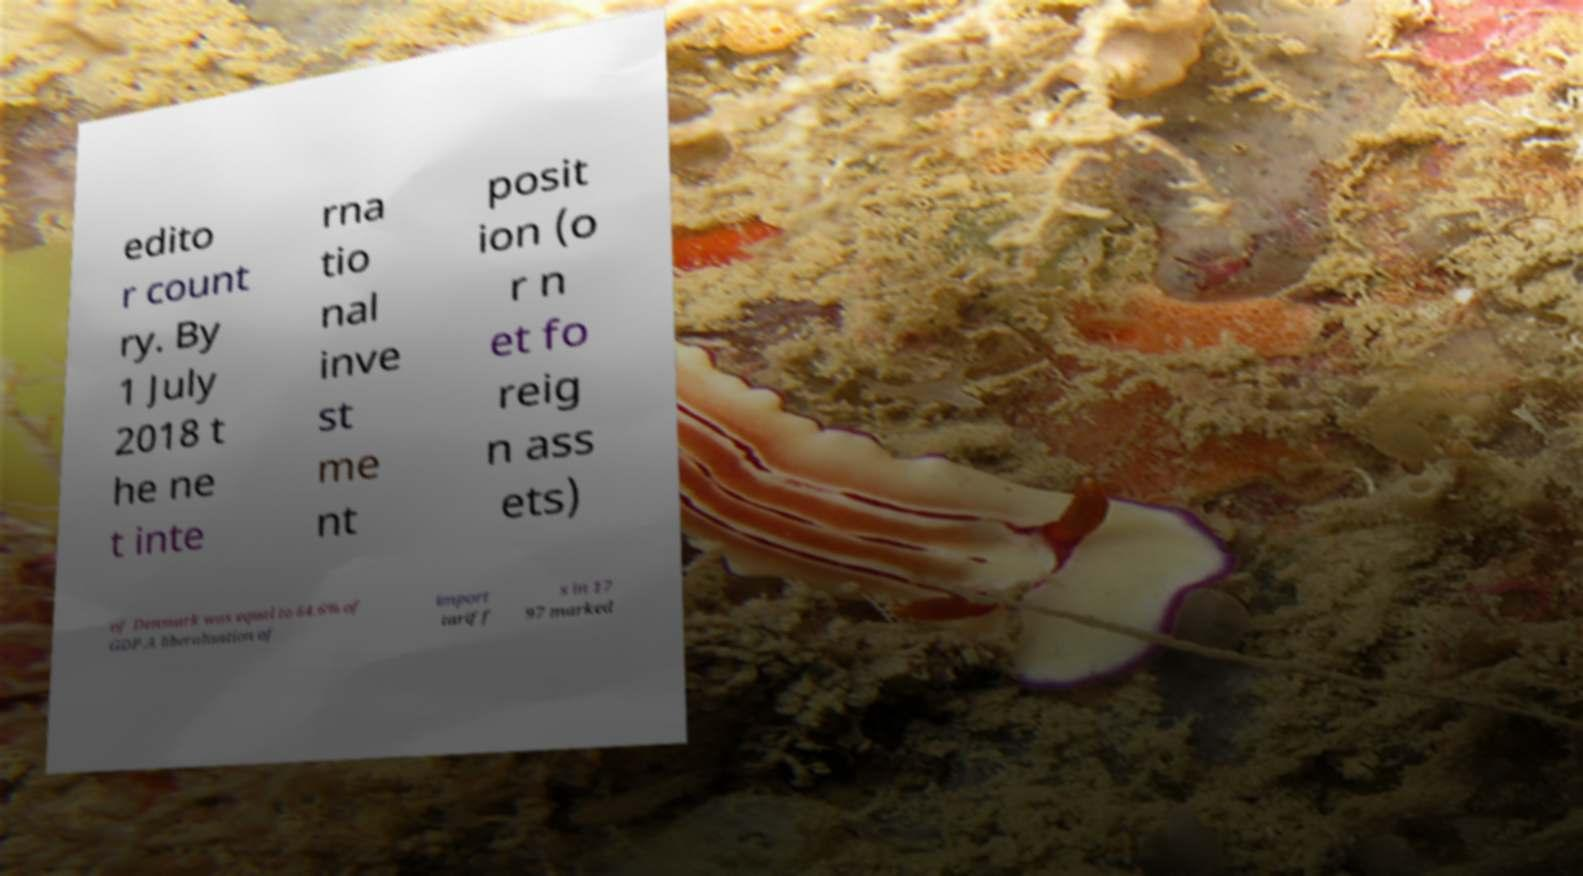For documentation purposes, I need the text within this image transcribed. Could you provide that? edito r count ry. By 1 July 2018 t he ne t inte rna tio nal inve st me nt posit ion (o r n et fo reig n ass ets) of Denmark was equal to 64.6% of GDP.A liberalisation of import tariff s in 17 97 marked 